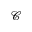Convert formula to latex. <formula><loc_0><loc_0><loc_500><loc_500>\ m a t h s c r { C }</formula> 